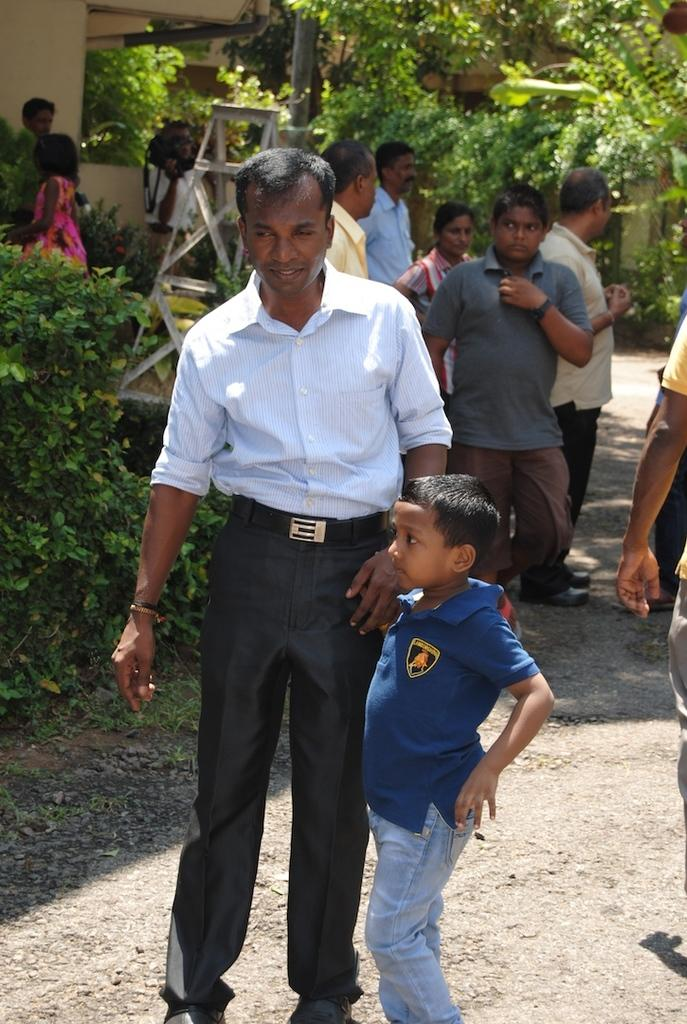What is the main subject in the image? There is a man standing in the image. Who is beside the man? There is a boy beside the man. What can be seen in the background of the image? There are plants, people, a ladder, a wall, and trees in the background of the image. How many ducks are sitting on the blade in the image? There are no ducks or blades present in the image. 